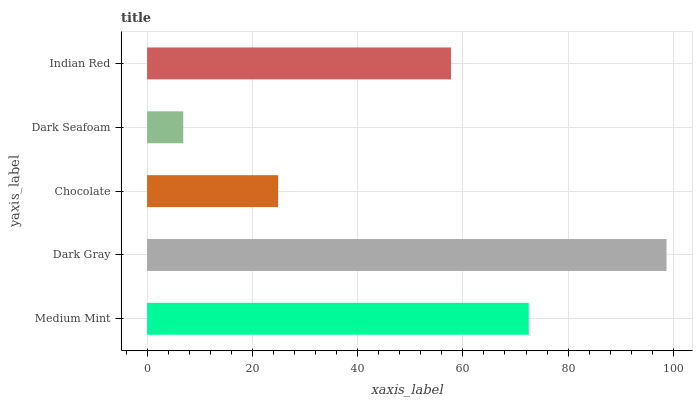Is Dark Seafoam the minimum?
Answer yes or no. Yes. Is Dark Gray the maximum?
Answer yes or no. Yes. Is Chocolate the minimum?
Answer yes or no. No. Is Chocolate the maximum?
Answer yes or no. No. Is Dark Gray greater than Chocolate?
Answer yes or no. Yes. Is Chocolate less than Dark Gray?
Answer yes or no. Yes. Is Chocolate greater than Dark Gray?
Answer yes or no. No. Is Dark Gray less than Chocolate?
Answer yes or no. No. Is Indian Red the high median?
Answer yes or no. Yes. Is Indian Red the low median?
Answer yes or no. Yes. Is Chocolate the high median?
Answer yes or no. No. Is Medium Mint the low median?
Answer yes or no. No. 